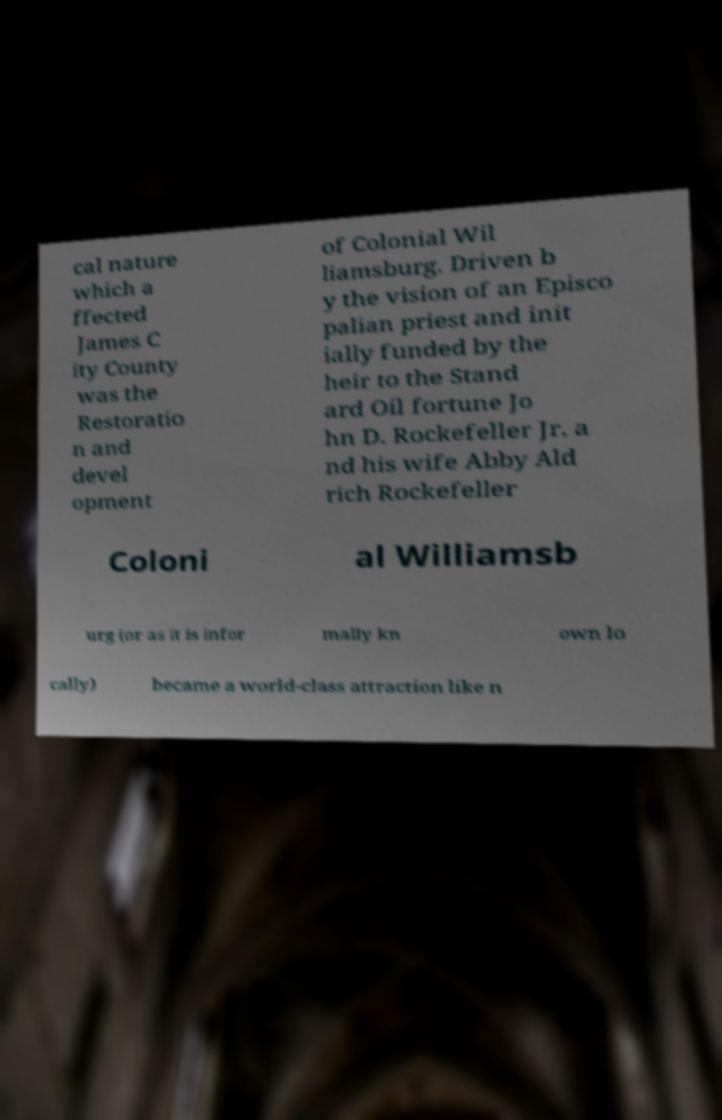Could you assist in decoding the text presented in this image and type it out clearly? cal nature which a ffected James C ity County was the Restoratio n and devel opment of Colonial Wil liamsburg. Driven b y the vision of an Episco palian priest and init ially funded by the heir to the Stand ard Oil fortune Jo hn D. Rockefeller Jr. a nd his wife Abby Ald rich Rockefeller Coloni al Williamsb urg (or as it is infor mally kn own lo cally) became a world-class attraction like n 